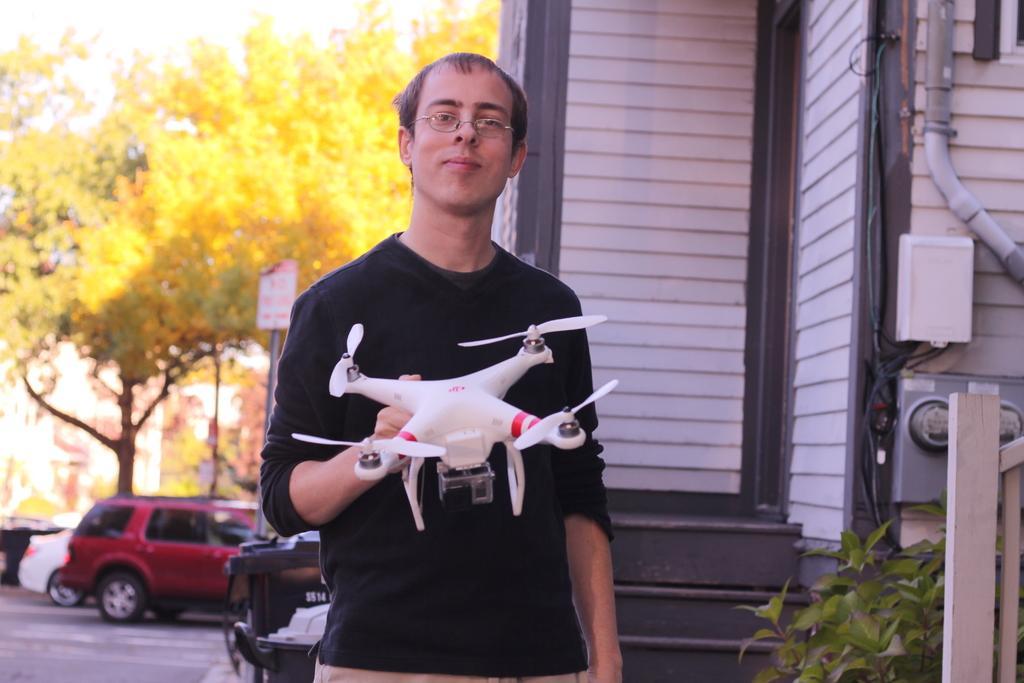Please provide a concise description of this image. In this picture we can see a man wearing full sleeves black t-shirt smiling in holding a white Drone in the hand. Behind there a wooden panel wall house and on the left side there are yellow color trees and two cars moving on the road. 